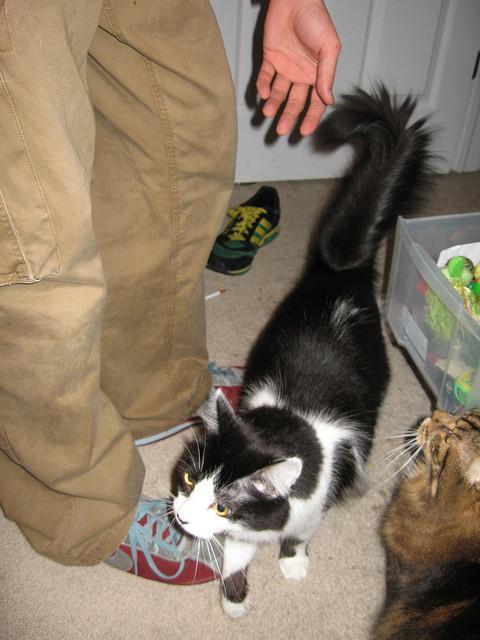How many tennis shoes are visible in the photo?
Give a very brief answer. 3. How many cats are there?
Give a very brief answer. 2. How many blue cars are there?
Give a very brief answer. 0. 